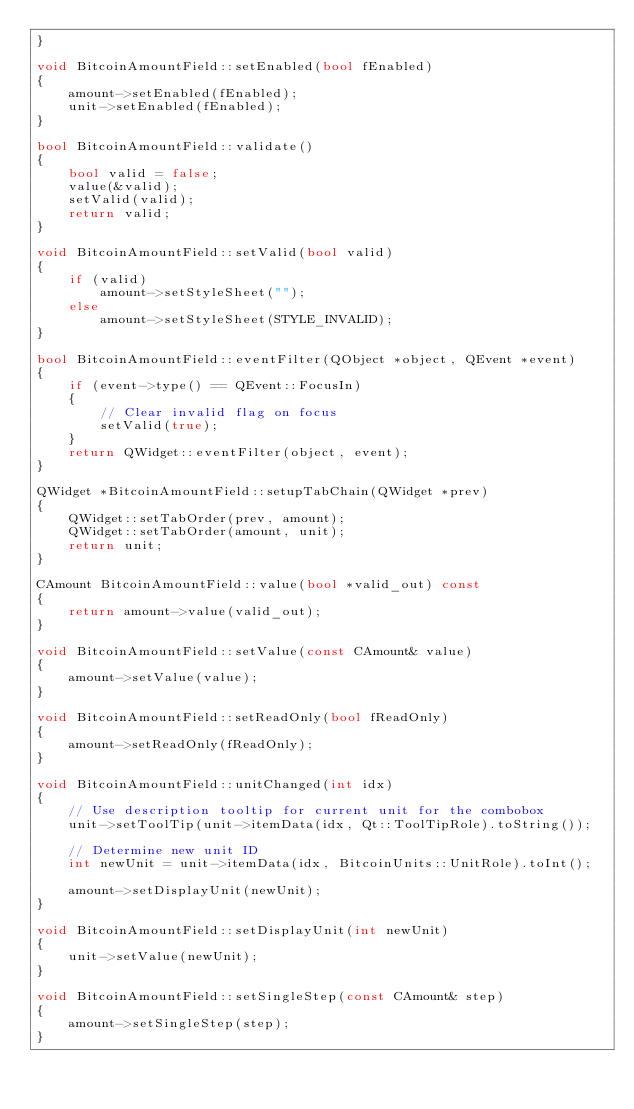<code> <loc_0><loc_0><loc_500><loc_500><_C++_>}

void BitcoinAmountField::setEnabled(bool fEnabled)
{
    amount->setEnabled(fEnabled);
    unit->setEnabled(fEnabled);
}

bool BitcoinAmountField::validate()
{
    bool valid = false;
    value(&valid);
    setValid(valid);
    return valid;
}

void BitcoinAmountField::setValid(bool valid)
{
    if (valid)
        amount->setStyleSheet("");
    else
        amount->setStyleSheet(STYLE_INVALID);
}

bool BitcoinAmountField::eventFilter(QObject *object, QEvent *event)
{
    if (event->type() == QEvent::FocusIn)
    {
        // Clear invalid flag on focus
        setValid(true);
    }
    return QWidget::eventFilter(object, event);
}

QWidget *BitcoinAmountField::setupTabChain(QWidget *prev)
{
    QWidget::setTabOrder(prev, amount);
    QWidget::setTabOrder(amount, unit);
    return unit;
}

CAmount BitcoinAmountField::value(bool *valid_out) const
{
    return amount->value(valid_out);
}

void BitcoinAmountField::setValue(const CAmount& value)
{
    amount->setValue(value);
}

void BitcoinAmountField::setReadOnly(bool fReadOnly)
{
    amount->setReadOnly(fReadOnly);
}

void BitcoinAmountField::unitChanged(int idx)
{
    // Use description tooltip for current unit for the combobox
    unit->setToolTip(unit->itemData(idx, Qt::ToolTipRole).toString());

    // Determine new unit ID
    int newUnit = unit->itemData(idx, BitcoinUnits::UnitRole).toInt();

    amount->setDisplayUnit(newUnit);
}

void BitcoinAmountField::setDisplayUnit(int newUnit)
{
    unit->setValue(newUnit);
}

void BitcoinAmountField::setSingleStep(const CAmount& step)
{
    amount->setSingleStep(step);
}
</code> 